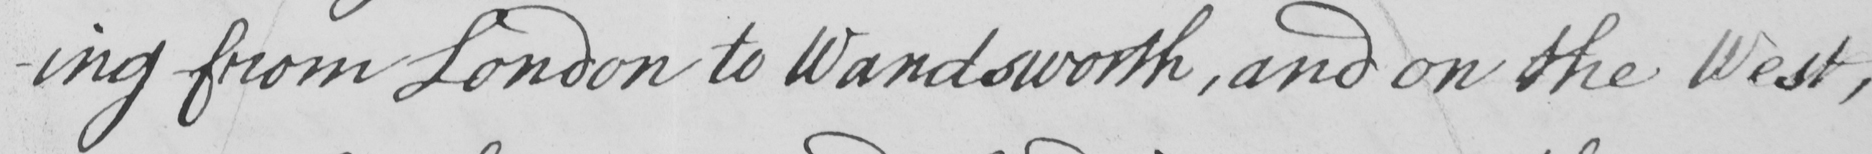Can you tell me what this handwritten text says? -ing from London to Wandsworth , and on the West , 